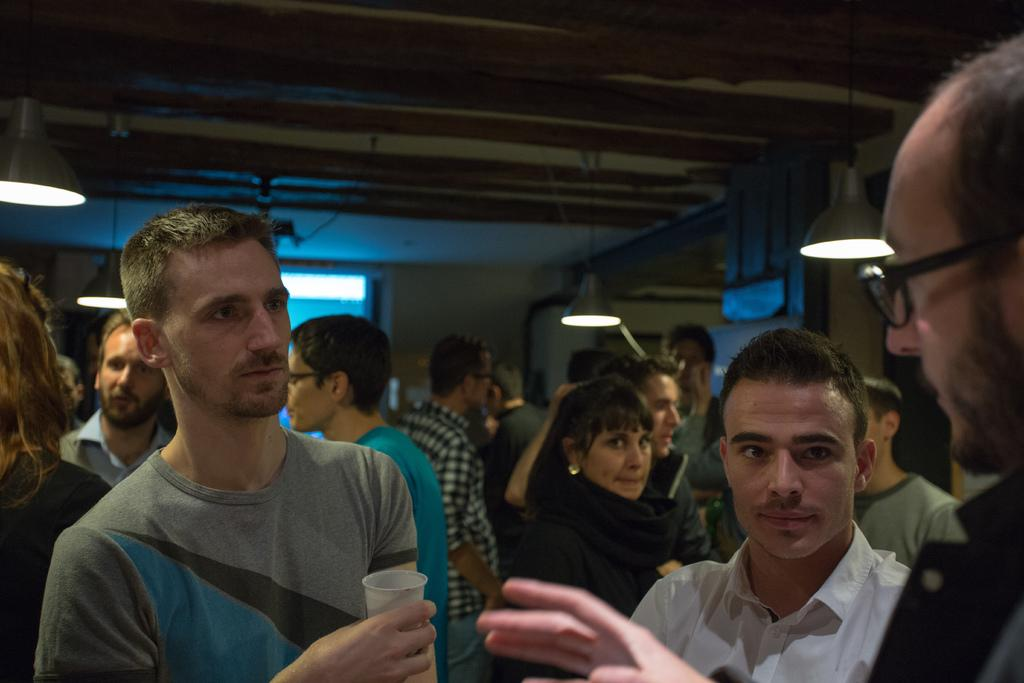What can be seen at the bottom of the image? There is a group of people standing at the bottom of the image. What is one person in the group holding? One person is holding a glass. What is visible in the background of the image? There is a wall, lights, rods, and a ceiling in the background of the image. What type of religious ceremony is taking place in the image? There is no indication of a religious ceremony in the image. How is the group of people divided in the image? The group of people is not divided in the image; they are standing together. 